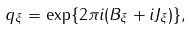Convert formula to latex. <formula><loc_0><loc_0><loc_500><loc_500>q _ { \xi } = \exp \{ 2 \pi i ( B _ { \xi } + i J _ { \xi } ) \} ,</formula> 